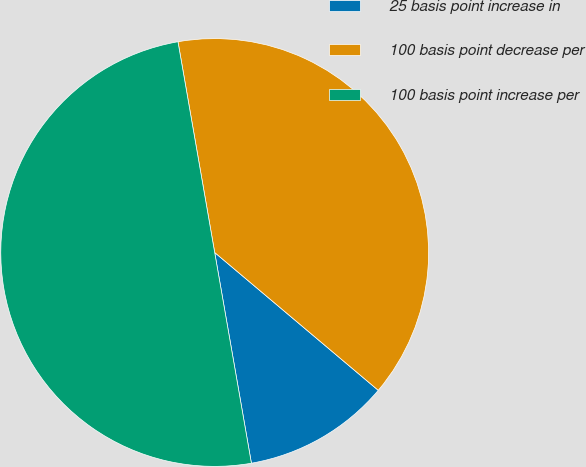<chart> <loc_0><loc_0><loc_500><loc_500><pie_chart><fcel>25 basis point increase in<fcel>100 basis point decrease per<fcel>100 basis point increase per<nl><fcel>11.11%<fcel>38.89%<fcel>50.0%<nl></chart> 